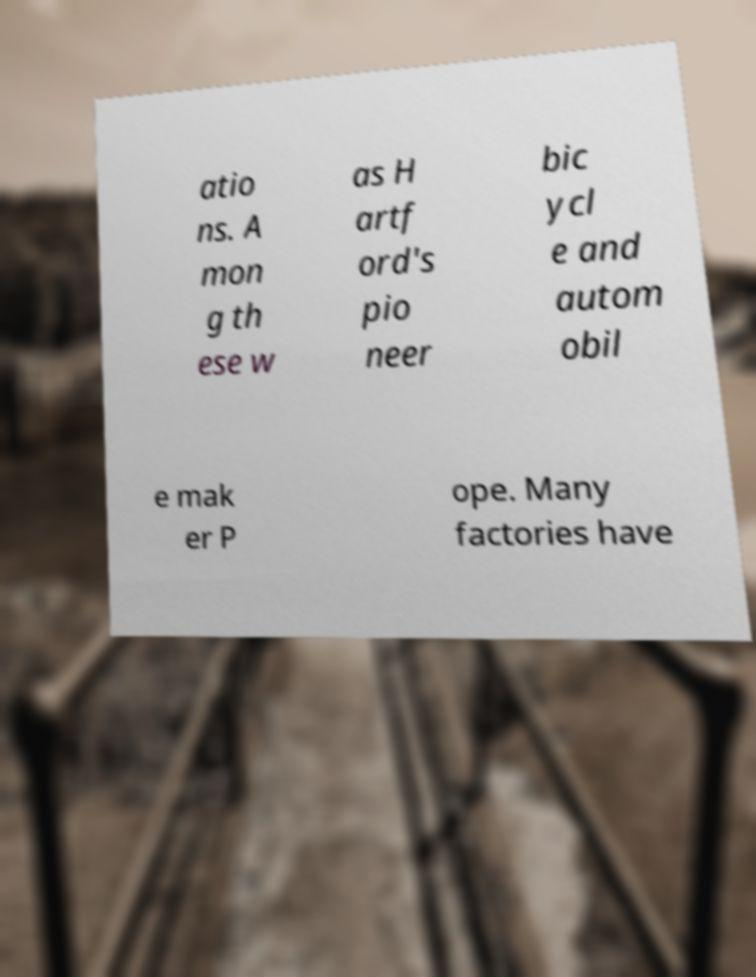Can you read and provide the text displayed in the image?This photo seems to have some interesting text. Can you extract and type it out for me? atio ns. A mon g th ese w as H artf ord's pio neer bic ycl e and autom obil e mak er P ope. Many factories have 